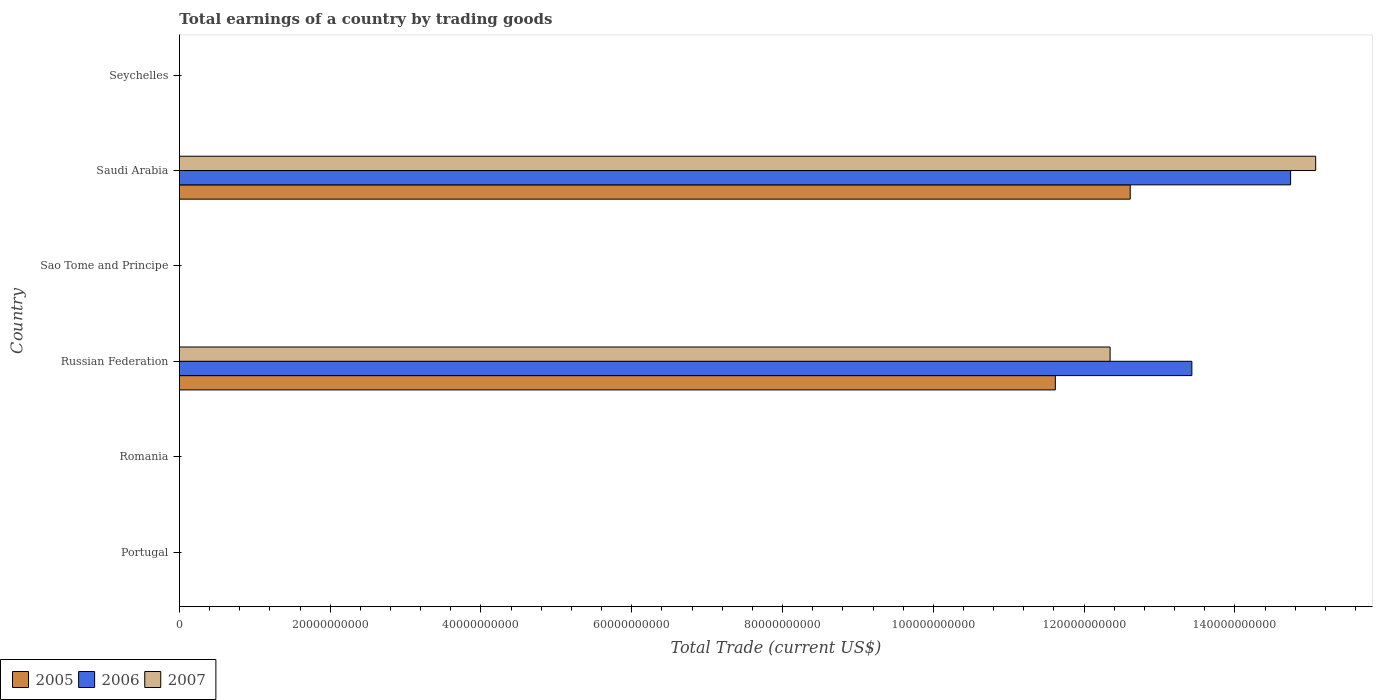Are the number of bars per tick equal to the number of legend labels?
Make the answer very short. No. How many bars are there on the 1st tick from the top?
Ensure brevity in your answer.  0. What is the label of the 3rd group of bars from the top?
Offer a terse response. Sao Tome and Principe. In how many cases, is the number of bars for a given country not equal to the number of legend labels?
Provide a succinct answer. 4. Across all countries, what is the maximum total earnings in 2006?
Provide a short and direct response. 1.47e+11. Across all countries, what is the minimum total earnings in 2005?
Offer a terse response. 0. In which country was the total earnings in 2006 maximum?
Make the answer very short. Saudi Arabia. What is the total total earnings in 2007 in the graph?
Offer a terse response. 2.74e+11. What is the difference between the total earnings in 2007 in Saudi Arabia and the total earnings in 2005 in Russian Federation?
Make the answer very short. 3.45e+1. What is the average total earnings in 2007 per country?
Offer a very short reply. 4.57e+1. What is the difference between the total earnings in 2005 and total earnings in 2007 in Saudi Arabia?
Keep it short and to the point. -2.46e+1. In how many countries, is the total earnings in 2007 greater than 84000000000 US$?
Your response must be concise. 2. What is the difference between the highest and the lowest total earnings in 2005?
Your answer should be compact. 1.26e+11. In how many countries, is the total earnings in 2007 greater than the average total earnings in 2007 taken over all countries?
Ensure brevity in your answer.  2. Is the sum of the total earnings in 2007 in Russian Federation and Saudi Arabia greater than the maximum total earnings in 2005 across all countries?
Your answer should be compact. Yes. Is it the case that in every country, the sum of the total earnings in 2007 and total earnings in 2006 is greater than the total earnings in 2005?
Make the answer very short. No. Are all the bars in the graph horizontal?
Offer a very short reply. Yes. Are the values on the major ticks of X-axis written in scientific E-notation?
Your answer should be compact. No. Does the graph contain any zero values?
Give a very brief answer. Yes. Does the graph contain grids?
Provide a short and direct response. No. How many legend labels are there?
Ensure brevity in your answer.  3. How are the legend labels stacked?
Provide a short and direct response. Horizontal. What is the title of the graph?
Keep it short and to the point. Total earnings of a country by trading goods. Does "1970" appear as one of the legend labels in the graph?
Offer a very short reply. No. What is the label or title of the X-axis?
Your answer should be compact. Total Trade (current US$). What is the Total Trade (current US$) in 2005 in Portugal?
Offer a very short reply. 0. What is the Total Trade (current US$) of 2006 in Romania?
Your response must be concise. 0. What is the Total Trade (current US$) of 2007 in Romania?
Ensure brevity in your answer.  0. What is the Total Trade (current US$) in 2005 in Russian Federation?
Your answer should be compact. 1.16e+11. What is the Total Trade (current US$) in 2006 in Russian Federation?
Make the answer very short. 1.34e+11. What is the Total Trade (current US$) of 2007 in Russian Federation?
Provide a succinct answer. 1.23e+11. What is the Total Trade (current US$) in 2007 in Sao Tome and Principe?
Ensure brevity in your answer.  0. What is the Total Trade (current US$) of 2005 in Saudi Arabia?
Provide a succinct answer. 1.26e+11. What is the Total Trade (current US$) of 2006 in Saudi Arabia?
Offer a very short reply. 1.47e+11. What is the Total Trade (current US$) of 2007 in Saudi Arabia?
Your answer should be very brief. 1.51e+11. What is the Total Trade (current US$) of 2005 in Seychelles?
Provide a succinct answer. 0. What is the Total Trade (current US$) in 2007 in Seychelles?
Offer a very short reply. 0. Across all countries, what is the maximum Total Trade (current US$) of 2005?
Give a very brief answer. 1.26e+11. Across all countries, what is the maximum Total Trade (current US$) of 2006?
Make the answer very short. 1.47e+11. Across all countries, what is the maximum Total Trade (current US$) in 2007?
Provide a succinct answer. 1.51e+11. Across all countries, what is the minimum Total Trade (current US$) of 2006?
Provide a succinct answer. 0. What is the total Total Trade (current US$) in 2005 in the graph?
Provide a short and direct response. 2.42e+11. What is the total Total Trade (current US$) in 2006 in the graph?
Ensure brevity in your answer.  2.82e+11. What is the total Total Trade (current US$) in 2007 in the graph?
Your answer should be very brief. 2.74e+11. What is the difference between the Total Trade (current US$) of 2005 in Russian Federation and that in Saudi Arabia?
Your answer should be very brief. -9.93e+09. What is the difference between the Total Trade (current US$) in 2006 in Russian Federation and that in Saudi Arabia?
Offer a very short reply. -1.31e+1. What is the difference between the Total Trade (current US$) of 2007 in Russian Federation and that in Saudi Arabia?
Keep it short and to the point. -2.73e+1. What is the difference between the Total Trade (current US$) of 2005 in Russian Federation and the Total Trade (current US$) of 2006 in Saudi Arabia?
Provide a succinct answer. -3.12e+1. What is the difference between the Total Trade (current US$) in 2005 in Russian Federation and the Total Trade (current US$) in 2007 in Saudi Arabia?
Your answer should be compact. -3.45e+1. What is the difference between the Total Trade (current US$) of 2006 in Russian Federation and the Total Trade (current US$) of 2007 in Saudi Arabia?
Ensure brevity in your answer.  -1.64e+1. What is the average Total Trade (current US$) in 2005 per country?
Make the answer very short. 4.04e+1. What is the average Total Trade (current US$) of 2006 per country?
Make the answer very short. 4.69e+1. What is the average Total Trade (current US$) in 2007 per country?
Provide a short and direct response. 4.57e+1. What is the difference between the Total Trade (current US$) of 2005 and Total Trade (current US$) of 2006 in Russian Federation?
Give a very brief answer. -1.81e+1. What is the difference between the Total Trade (current US$) of 2005 and Total Trade (current US$) of 2007 in Russian Federation?
Your answer should be compact. -7.26e+09. What is the difference between the Total Trade (current US$) in 2006 and Total Trade (current US$) in 2007 in Russian Federation?
Keep it short and to the point. 1.08e+1. What is the difference between the Total Trade (current US$) of 2005 and Total Trade (current US$) of 2006 in Saudi Arabia?
Offer a very short reply. -2.13e+1. What is the difference between the Total Trade (current US$) in 2005 and Total Trade (current US$) in 2007 in Saudi Arabia?
Provide a succinct answer. -2.46e+1. What is the difference between the Total Trade (current US$) in 2006 and Total Trade (current US$) in 2007 in Saudi Arabia?
Make the answer very short. -3.32e+09. What is the ratio of the Total Trade (current US$) of 2005 in Russian Federation to that in Saudi Arabia?
Give a very brief answer. 0.92. What is the ratio of the Total Trade (current US$) of 2006 in Russian Federation to that in Saudi Arabia?
Keep it short and to the point. 0.91. What is the ratio of the Total Trade (current US$) in 2007 in Russian Federation to that in Saudi Arabia?
Provide a succinct answer. 0.82. What is the difference between the highest and the lowest Total Trade (current US$) in 2005?
Your answer should be compact. 1.26e+11. What is the difference between the highest and the lowest Total Trade (current US$) in 2006?
Offer a very short reply. 1.47e+11. What is the difference between the highest and the lowest Total Trade (current US$) in 2007?
Offer a very short reply. 1.51e+11. 